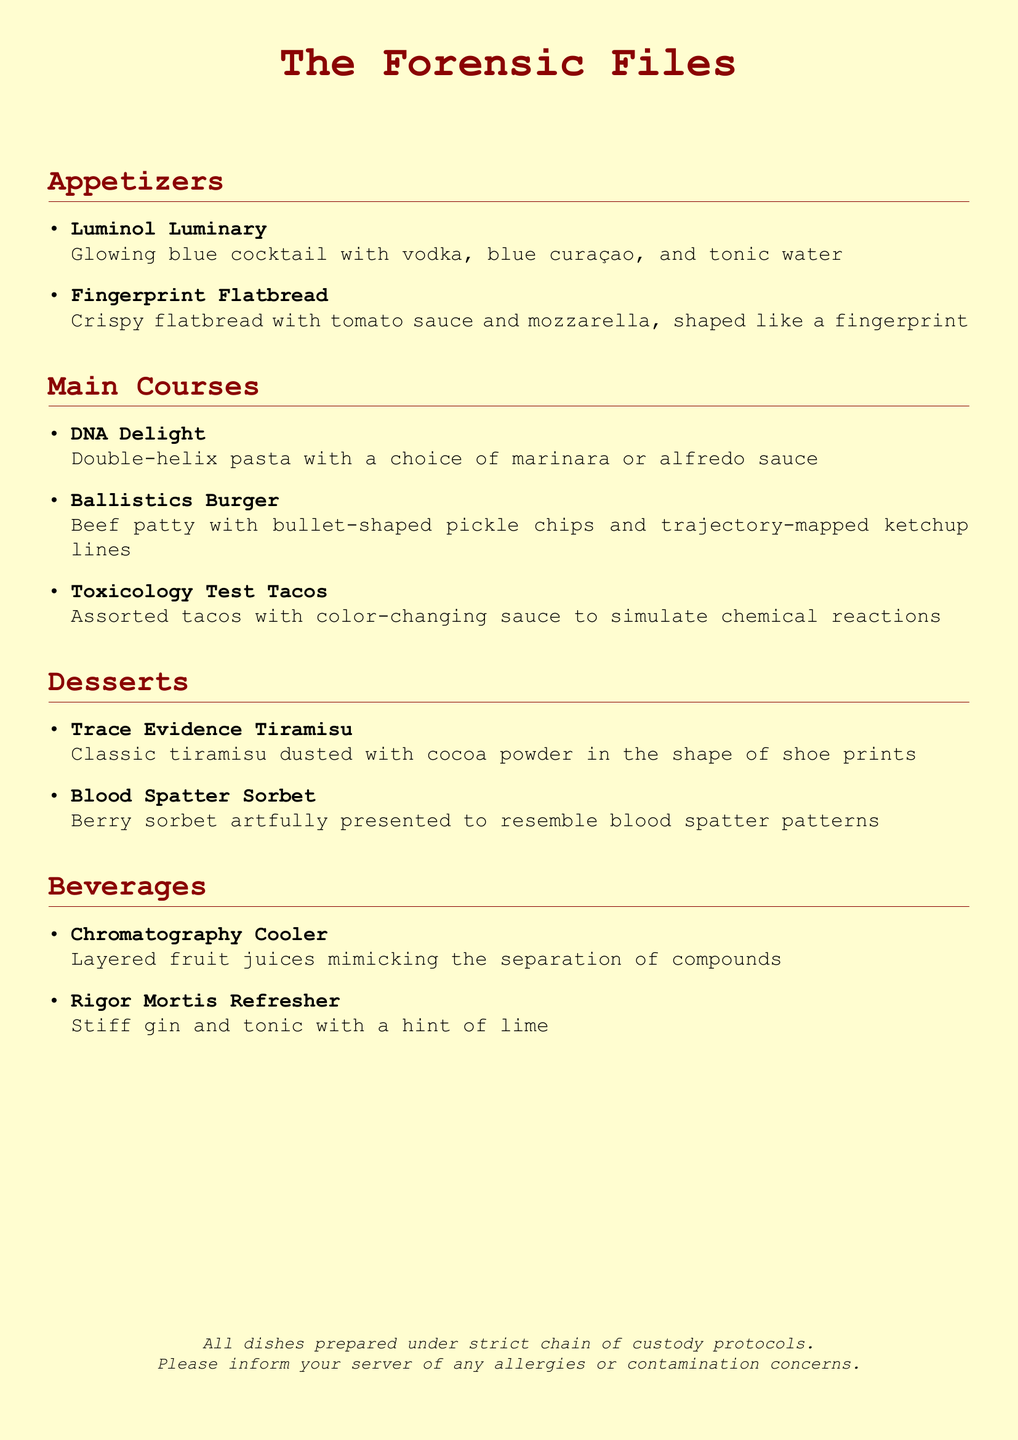What is the name of the cocktail that glows blue? The glowing blue cocktail is named "Luminol Luminary."
Answer: Luminol Luminary How many main courses are listed on the menu? There are three main courses listed in the menu section.
Answer: 3 What unique shape is the Fingerprint Flatbread designed to resemble? The Fingerprint Flatbread is shaped like a fingerprint.
Answer: fingerprint What dessert resembles a blood spatter pattern? The dessert that resembles blood spatter patterns is called "Blood Spatter Sorbet."
Answer: Blood Spatter Sorbet Which drink features layered fruit juices? The drink with layered fruit juices is named "Chromatography Cooler."
Answer: Chromatography Cooler What type of pasta is served in the DNA Delight dish? The DNA Delight dish is served with double-helix pasta.
Answer: double-helix What is the color theme of the menu's background? The background color theme of the menu is described as crimescene yellow.
Answer: crimescene yellow What type of tacos simulate chemical reactions? The tacos that simulate chemical reactions are called "Toxicology Test Tacos."
Answer: Toxicology Test Tacos Which dessert is dusted with cocoa powder in the shape of shoe prints? The dessert that is dusted with cocoa powder in the shape of shoe prints is "Trace Evidence Tiramisu."
Answer: Trace Evidence Tiramisu 